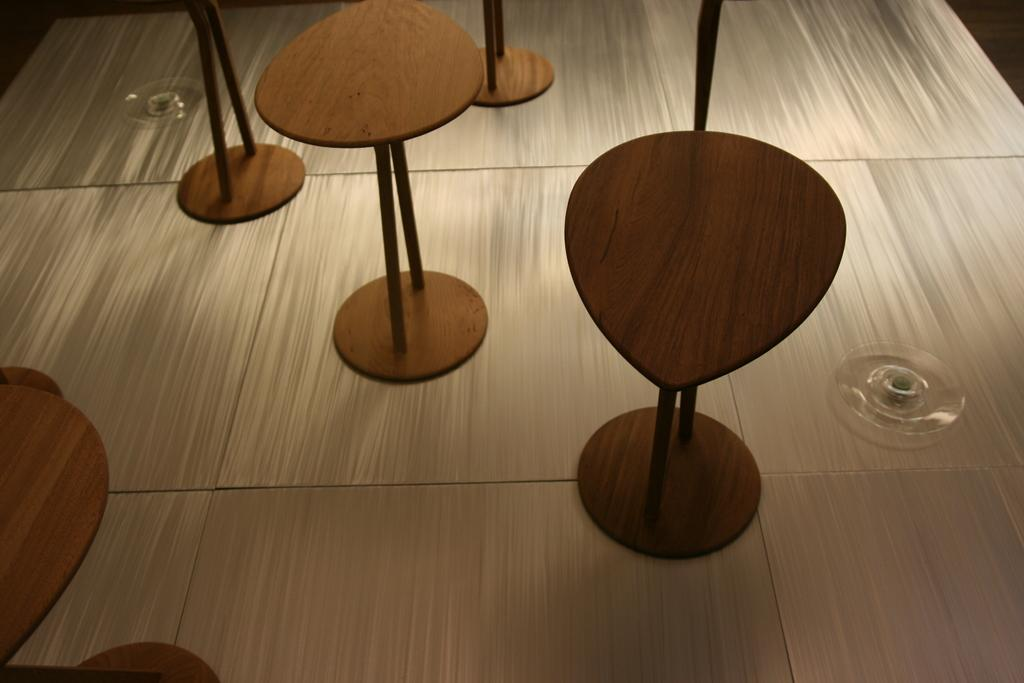What type of furniture is visible in the image? There are empty stools in the image. What material are the glass objects made of? The glass objects in the image are made of glass. What type of watch is visible on the stool in the image? There is no watch present in the image; only empty stools and glass objects are visible. What observation can be made about the behavior of the cub in the image? There is no cub present in the image, so no observation about its behavior can be made. 